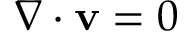Convert formula to latex. <formula><loc_0><loc_0><loc_500><loc_500>\nabla \cdot v = 0</formula> 